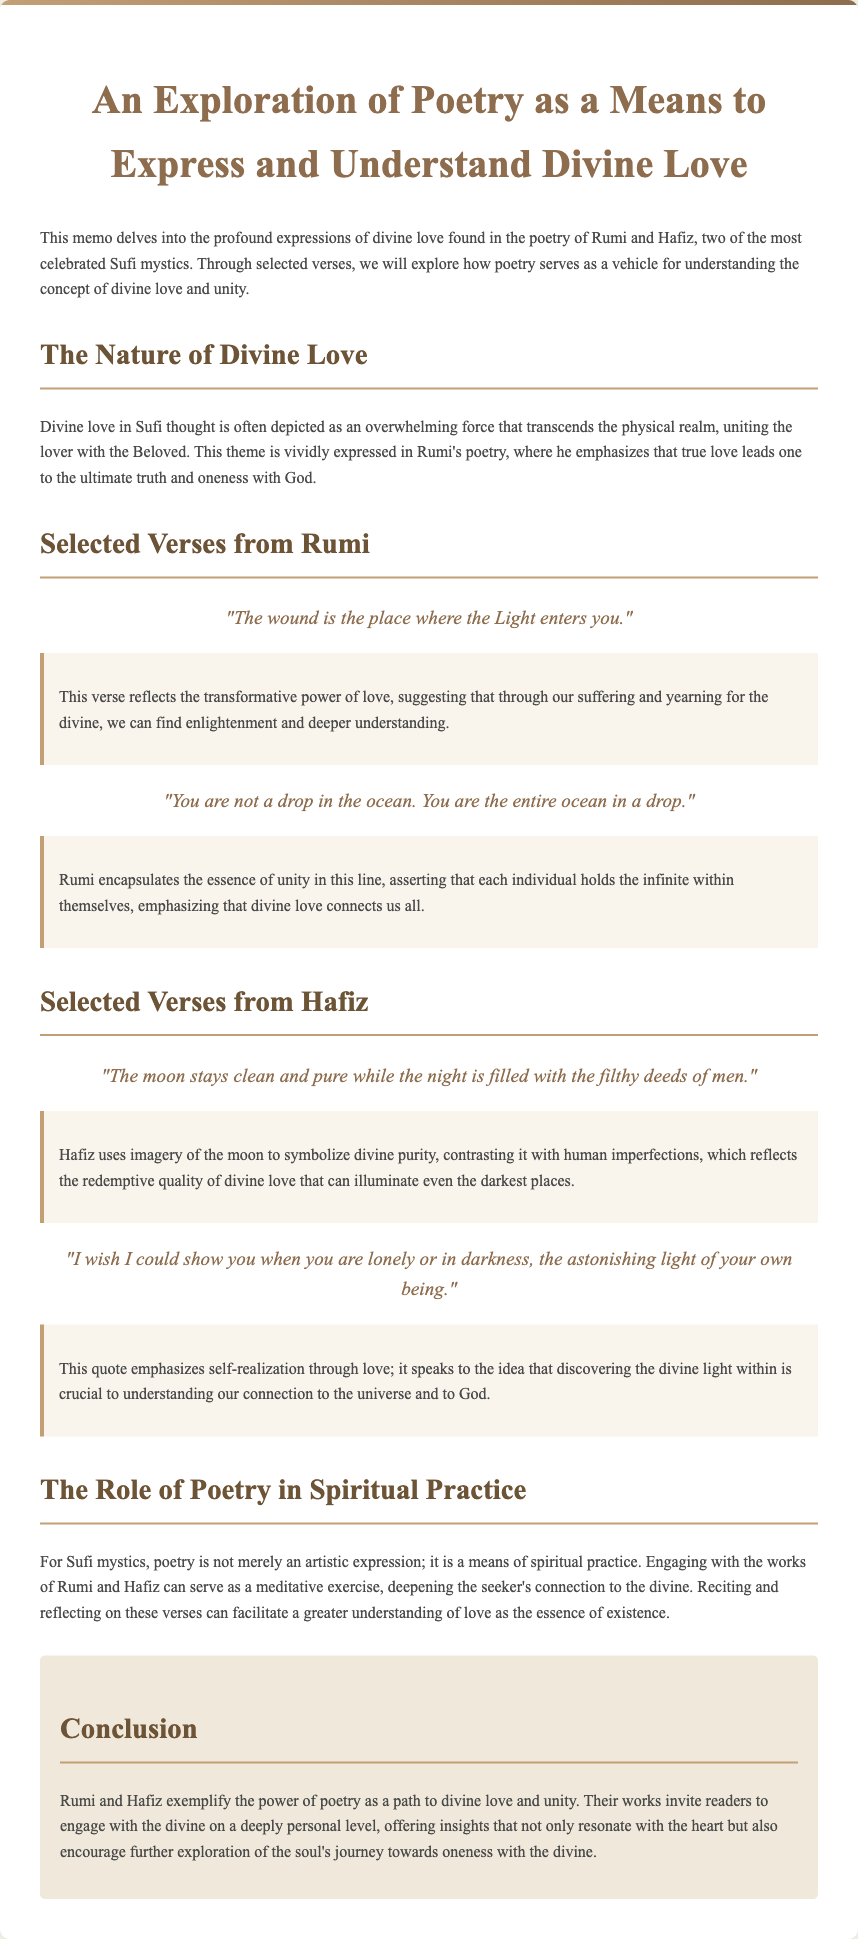what is the title of the memo? The title of the memo is prominently displayed at the top of the document.
Answer: An Exploration of Poetry as a Means to Express and Understand Divine Love who are the two poets featured in the memo? The memo focuses on the works of two celebrated Sufi mystics, whose names are stated in the introduction.
Answer: Rumi and Hafiz what does Rumi say about the ocean? This verse from Rumi is highlighted in the section covering his selected verses, expressing a profound thought.
Answer: "You are not a drop in the ocean. You are the entire ocean in a drop." what is the significance of poetry in Sufi mysticism? The memo explains the role of poetry in spiritual practice, detailing how it connects to divine love.
Answer: A means of spiritual practice what illuminates even the darkest places according to Hafiz? This concept is derived from Hafiz's examination of divine purity in contrast to human flaws, mentioned in his selected verses.
Answer: Divine love how does Rumi express the idea of transformation through love? This thematic exploration can be found in one of the selected verses with a direct quote that shows this idea.
Answer: "The wound is the place where the Light enters you." what is the conclusion about the works of Rumi and Hafiz? The conclusion summarizes the overall message of the document regarding the poets' contributions to understanding divine love.
Answer: Offer insights that not only resonate with the heart but also encourage further exploration of the soul's journey towards oneness with the divine 